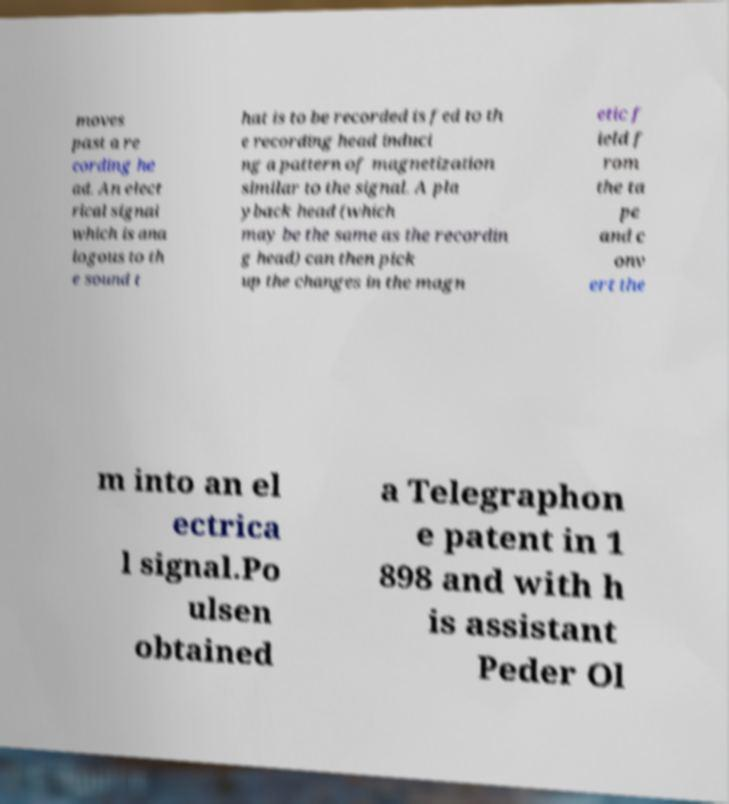What messages or text are displayed in this image? I need them in a readable, typed format. moves past a re cording he ad. An elect rical signal which is ana logous to th e sound t hat is to be recorded is fed to th e recording head induci ng a pattern of magnetization similar to the signal. A pla yback head (which may be the same as the recordin g head) can then pick up the changes in the magn etic f ield f rom the ta pe and c onv ert the m into an el ectrica l signal.Po ulsen obtained a Telegraphon e patent in 1 898 and with h is assistant Peder Ol 